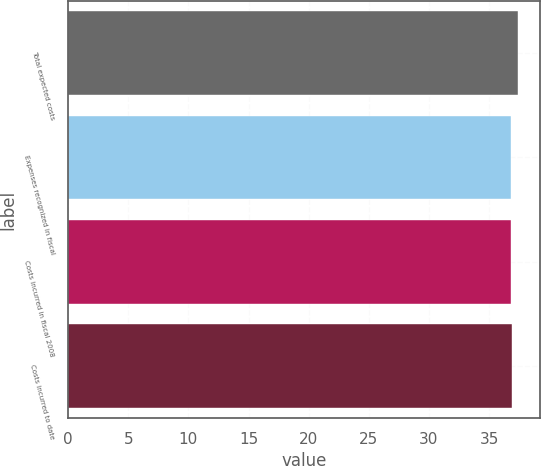Convert chart to OTSL. <chart><loc_0><loc_0><loc_500><loc_500><bar_chart><fcel>Total expected costs<fcel>Expenses recognized in fiscal<fcel>Costs incurred in fiscal 2008<fcel>Costs incurred to date<nl><fcel>37.4<fcel>36.8<fcel>36.86<fcel>36.92<nl></chart> 